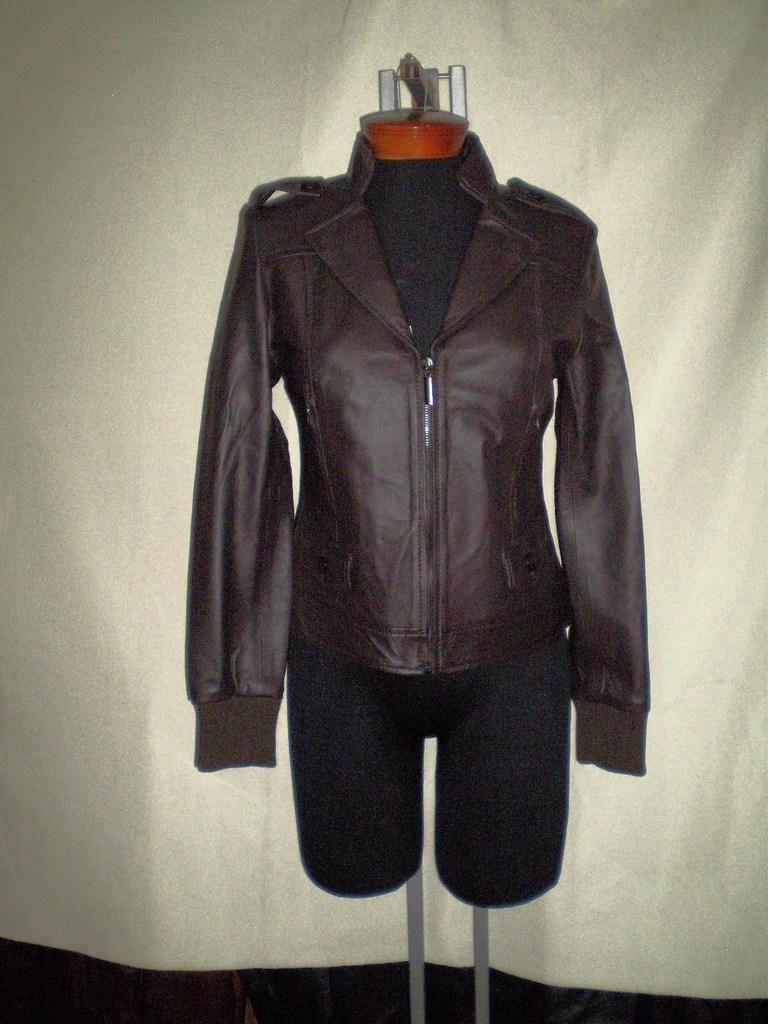What is the main subject of the image? There is a mannequin in the image. What is the mannequin wearing? The mannequin is wearing clothes. What can be seen in the background of the image? There is a curtain in the background of the image. How many people are visiting the cemetery in the image? There is no cemetery present in the image, so it is not possible to determine how many people might be visiting one. 